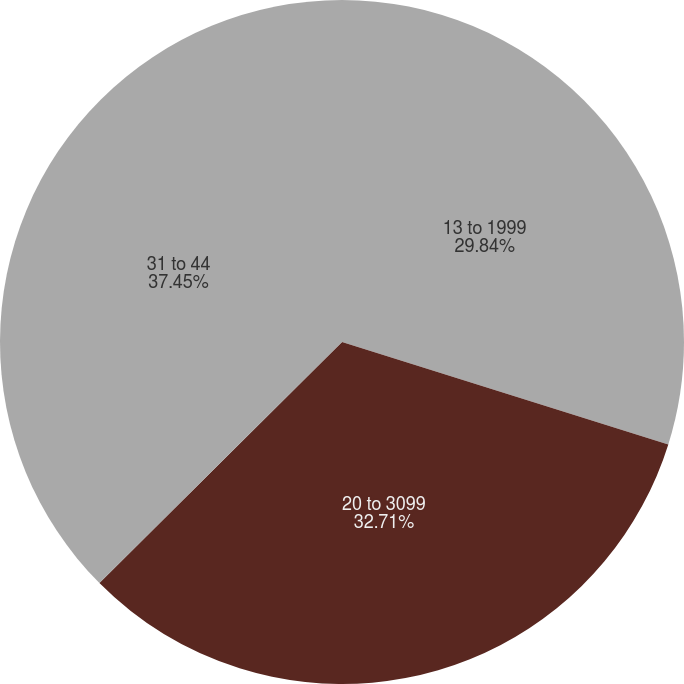Convert chart. <chart><loc_0><loc_0><loc_500><loc_500><pie_chart><fcel>13 to 1999<fcel>20 to 3099<fcel>31 to 44<nl><fcel>29.84%<fcel>32.71%<fcel>37.45%<nl></chart> 